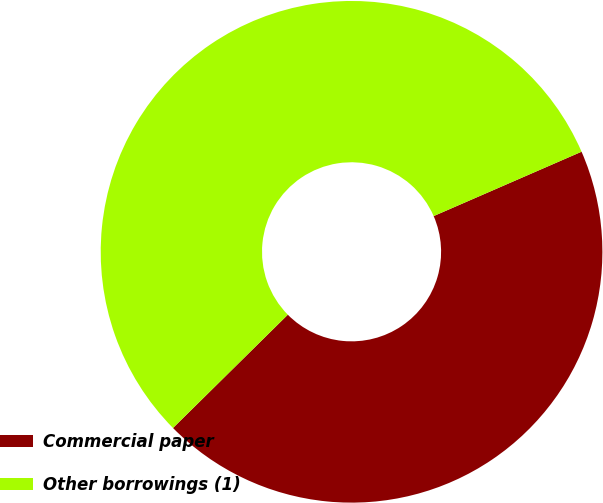Convert chart. <chart><loc_0><loc_0><loc_500><loc_500><pie_chart><fcel>Commercial paper<fcel>Other borrowings (1)<nl><fcel>44.14%<fcel>55.86%<nl></chart> 